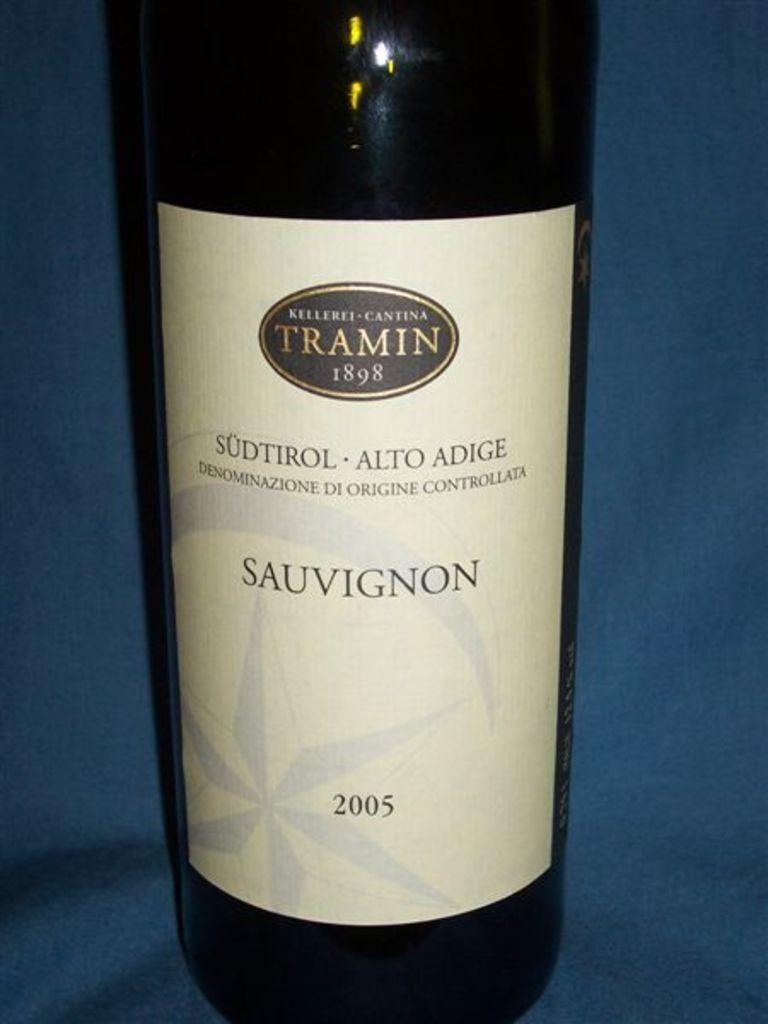Provide a one-sentence caption for the provided image. A bottle of sauvignon wine from the maker Tramin. 